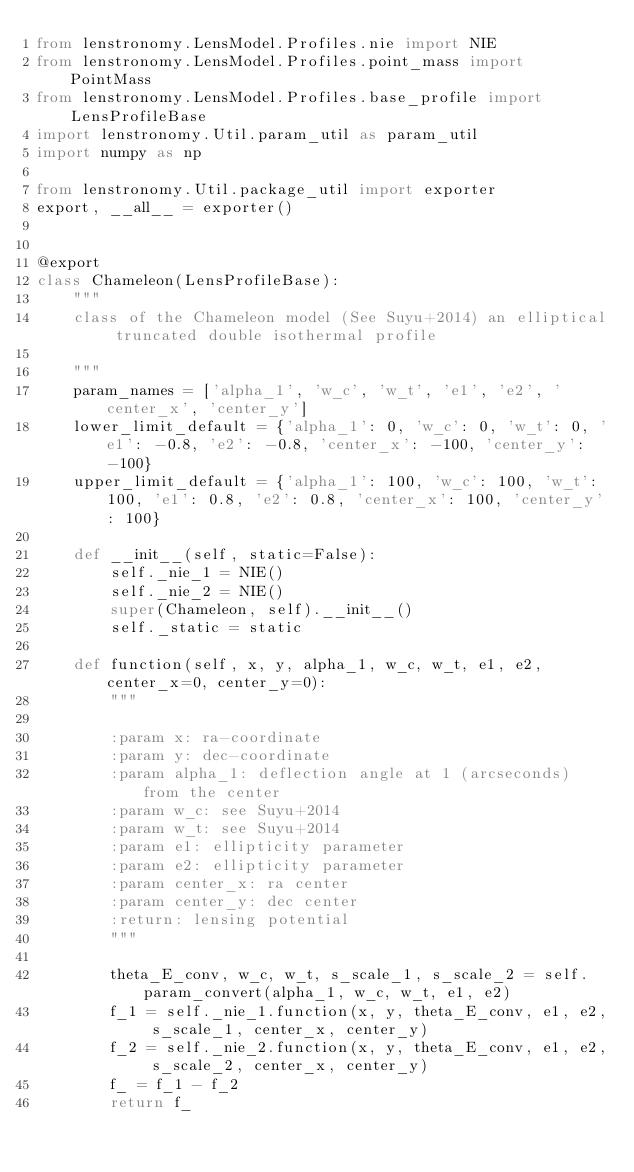Convert code to text. <code><loc_0><loc_0><loc_500><loc_500><_Python_>from lenstronomy.LensModel.Profiles.nie import NIE
from lenstronomy.LensModel.Profiles.point_mass import PointMass
from lenstronomy.LensModel.Profiles.base_profile import LensProfileBase
import lenstronomy.Util.param_util as param_util
import numpy as np

from lenstronomy.Util.package_util import exporter
export, __all__ = exporter()


@export
class Chameleon(LensProfileBase):
    """
    class of the Chameleon model (See Suyu+2014) an elliptical truncated double isothermal profile

    """
    param_names = ['alpha_1', 'w_c', 'w_t', 'e1', 'e2', 'center_x', 'center_y']
    lower_limit_default = {'alpha_1': 0, 'w_c': 0, 'w_t': 0, 'e1': -0.8, 'e2': -0.8, 'center_x': -100, 'center_y': -100}
    upper_limit_default = {'alpha_1': 100, 'w_c': 100, 'w_t': 100, 'e1': 0.8, 'e2': 0.8, 'center_x': 100, 'center_y': 100}

    def __init__(self, static=False):
        self._nie_1 = NIE()
        self._nie_2 = NIE()
        super(Chameleon, self).__init__()
        self._static = static

    def function(self, x, y, alpha_1, w_c, w_t, e1, e2, center_x=0, center_y=0):
        """

        :param x: ra-coordinate
        :param y: dec-coordinate
        :param alpha_1: deflection angle at 1 (arcseconds) from the center
        :param w_c: see Suyu+2014
        :param w_t: see Suyu+2014
        :param e1: ellipticity parameter
        :param e2: ellipticity parameter
        :param center_x: ra center
        :param center_y: dec center
        :return: lensing potential
        """

        theta_E_conv, w_c, w_t, s_scale_1, s_scale_2 = self.param_convert(alpha_1, w_c, w_t, e1, e2)
        f_1 = self._nie_1.function(x, y, theta_E_conv, e1, e2, s_scale_1, center_x, center_y)
        f_2 = self._nie_2.function(x, y, theta_E_conv, e1, e2, s_scale_2, center_x, center_y)
        f_ = f_1 - f_2
        return f_
</code> 